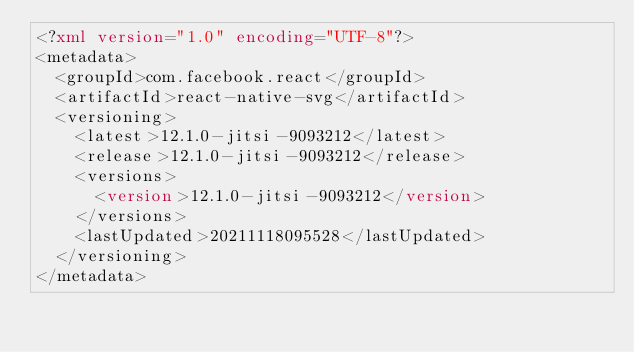Convert code to text. <code><loc_0><loc_0><loc_500><loc_500><_XML_><?xml version="1.0" encoding="UTF-8"?>
<metadata>
  <groupId>com.facebook.react</groupId>
  <artifactId>react-native-svg</artifactId>
  <versioning>
    <latest>12.1.0-jitsi-9093212</latest>
    <release>12.1.0-jitsi-9093212</release>
    <versions>
      <version>12.1.0-jitsi-9093212</version>
    </versions>
    <lastUpdated>20211118095528</lastUpdated>
  </versioning>
</metadata>
</code> 